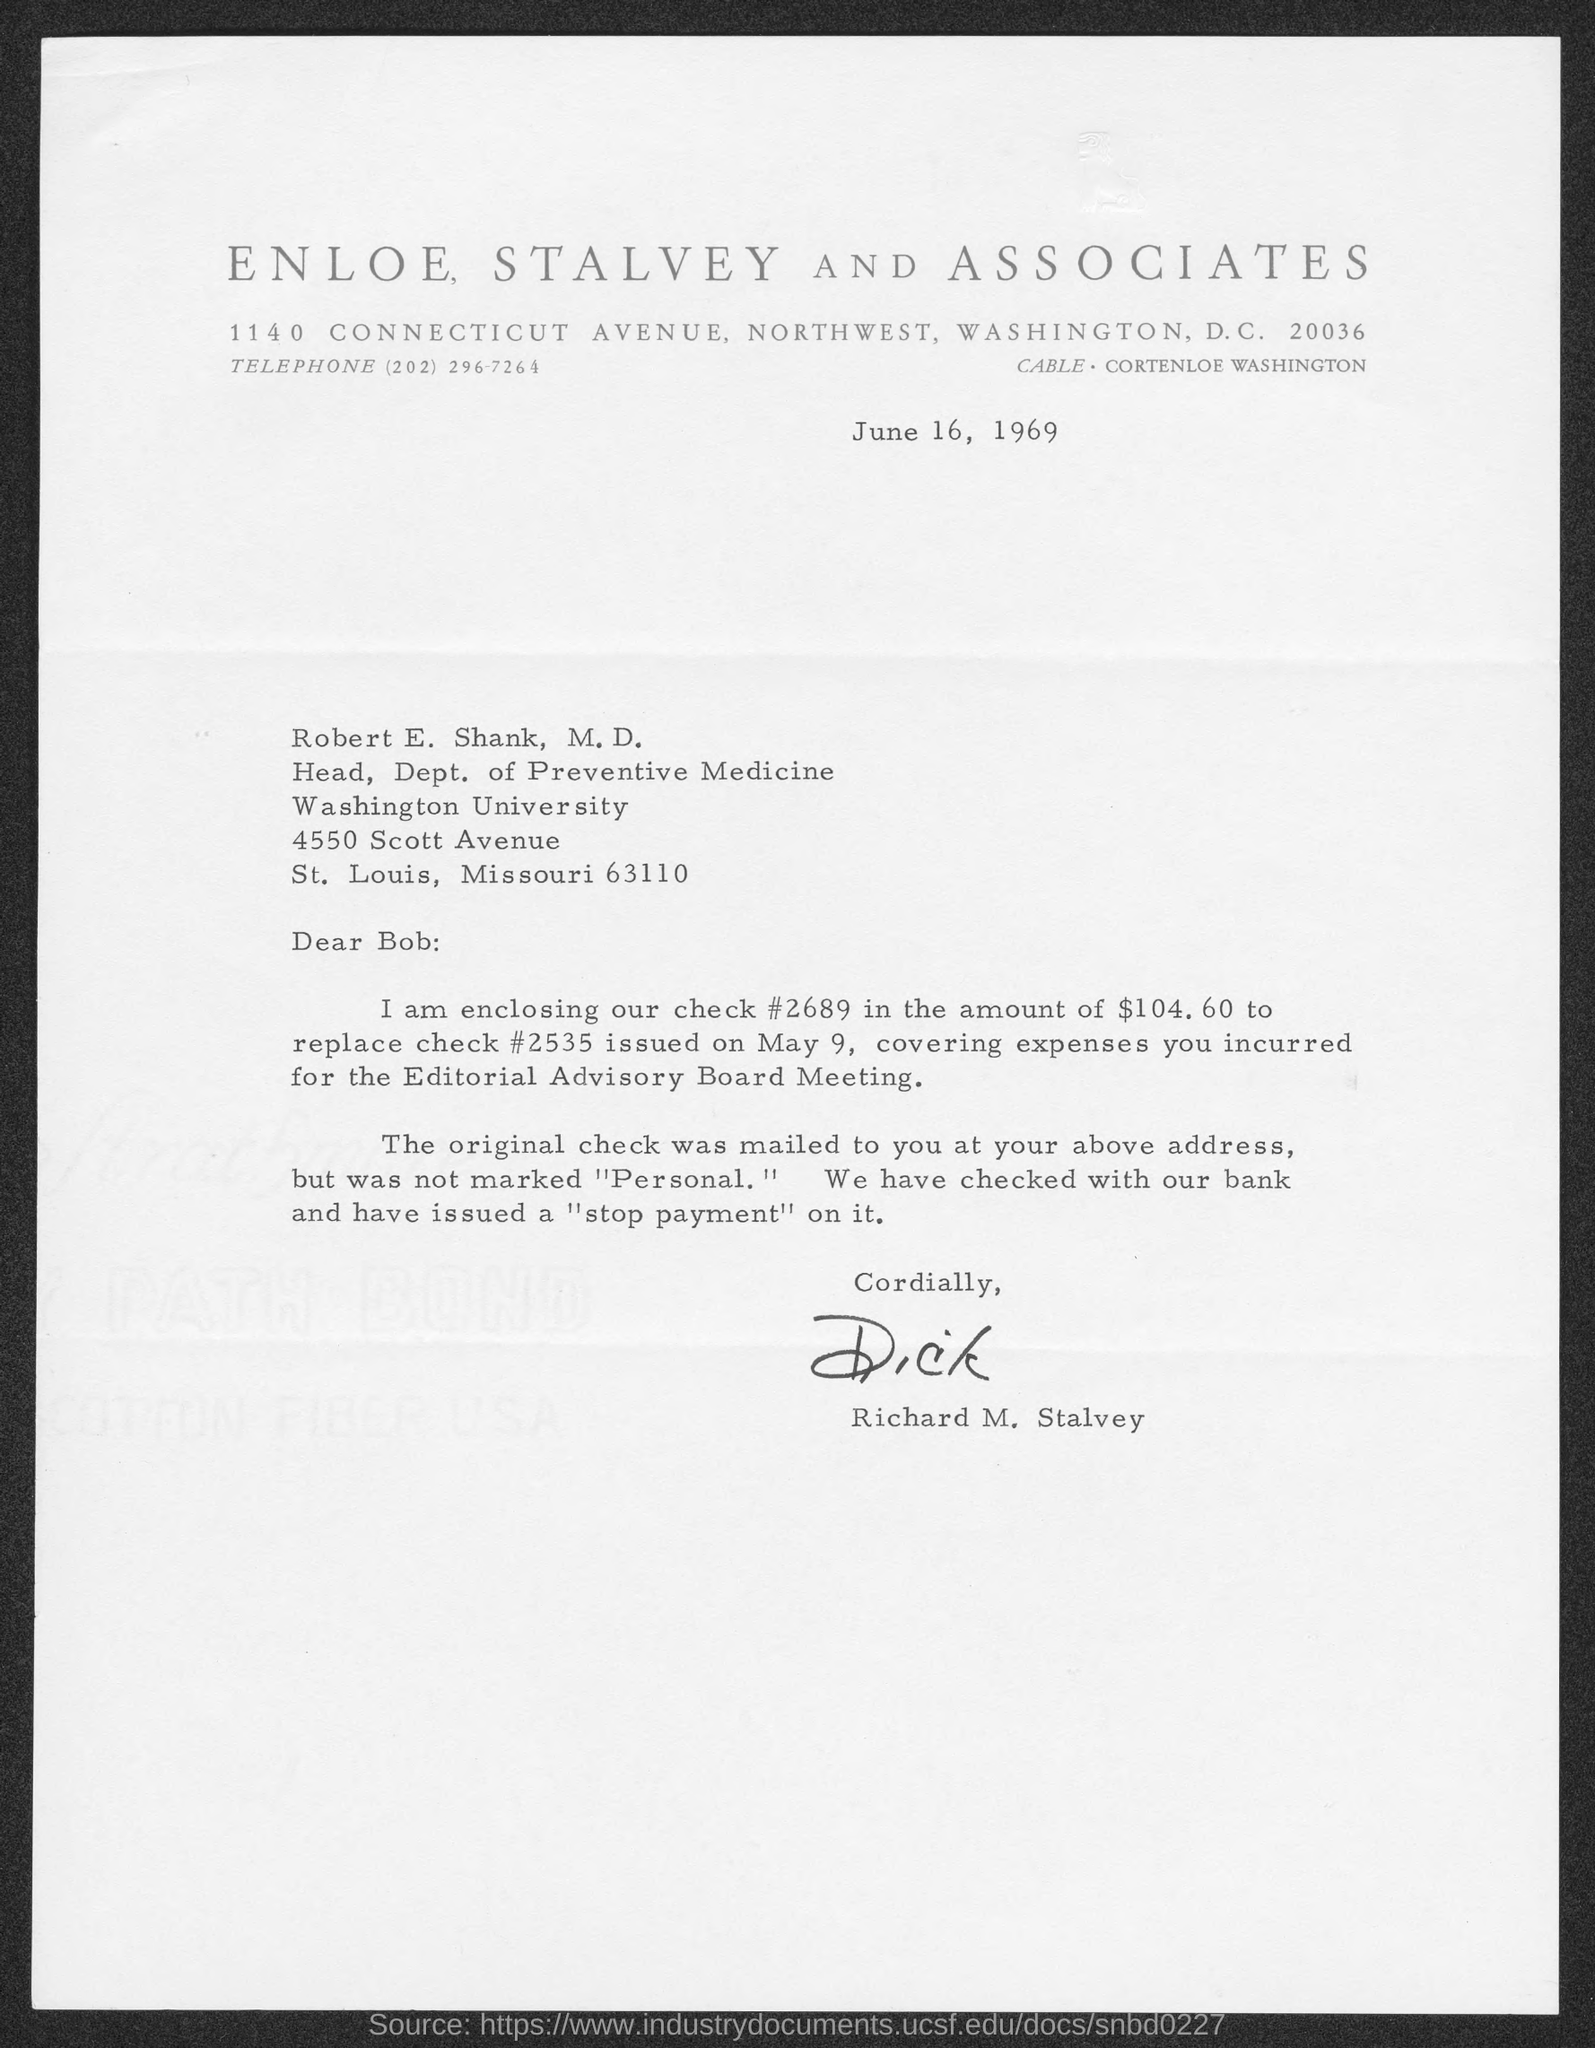Indicate a few pertinent items in this graphic. The letter is dated June 16, 1969. The person who wrote this letter is Dick. The address of Enloe, Stalvey and Associates is located at 1140 Connecticut Avenue, Northwest, Washington D.C. 20036. Robert E. Shank, M.D. holds the position of Head of the Department of Preventive Medicine. The letter is addressed to Dr. Robert E. Shank. 